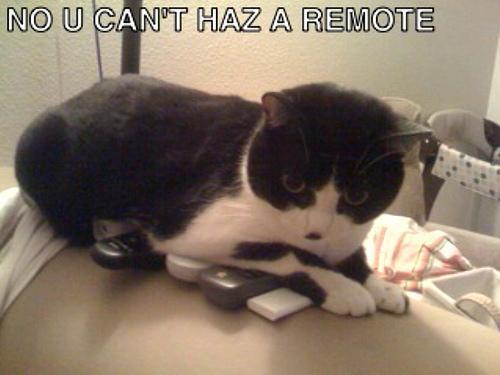How many remotes are visible?
Give a very brief answer. 2. 